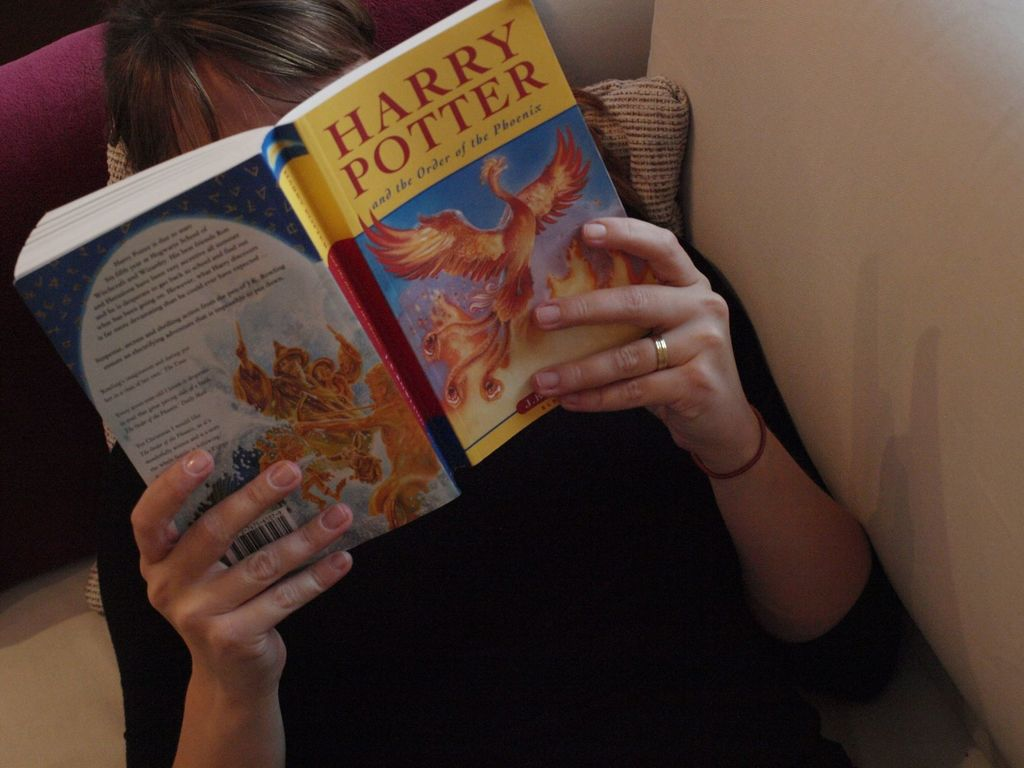Could you describe the design of the book cover shown in the image? The cover of the book features a striking illustration of a phoenix poised in flight against a backdrop of blue and gold hues. The phoenix, a mythical bird that symbolizes renewal and immortality, is aptly represented with fiery red and gold feathers, looking majestic and vibrant. This design is not only captivating but also thematically significant to the story's exploration of themes such as rebirth and facing adversity. 